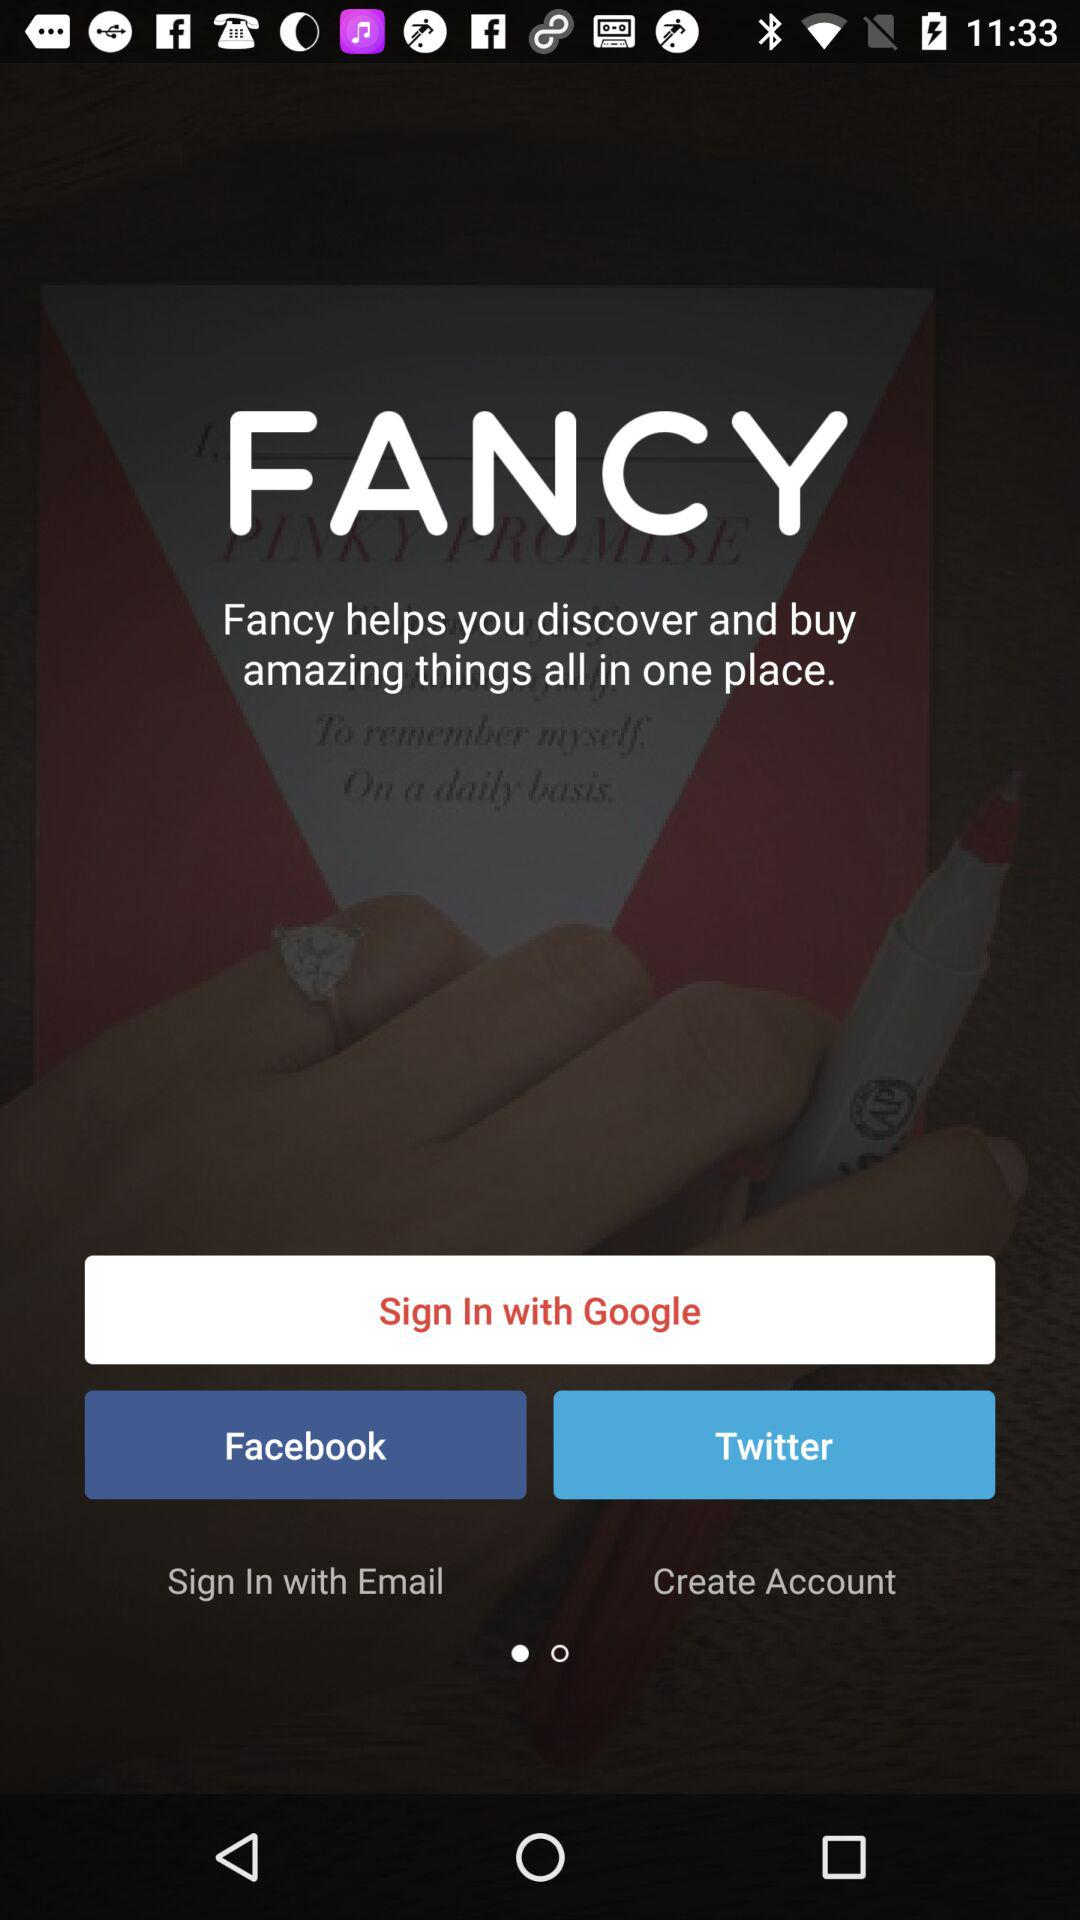How much do items in "FANCY" cost?
When the provided information is insufficient, respond with <no answer>. <no answer> 